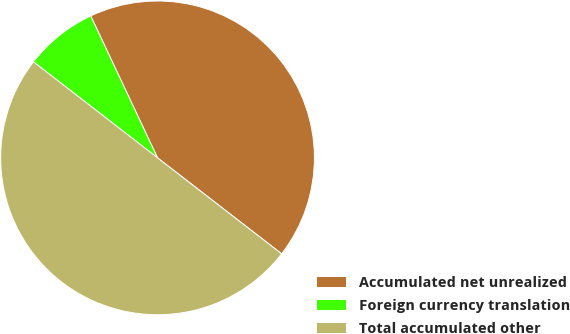Convert chart to OTSL. <chart><loc_0><loc_0><loc_500><loc_500><pie_chart><fcel>Accumulated net unrealized<fcel>Foreign currency translation<fcel>Total accumulated other<nl><fcel>42.48%<fcel>7.52%<fcel>50.0%<nl></chart> 